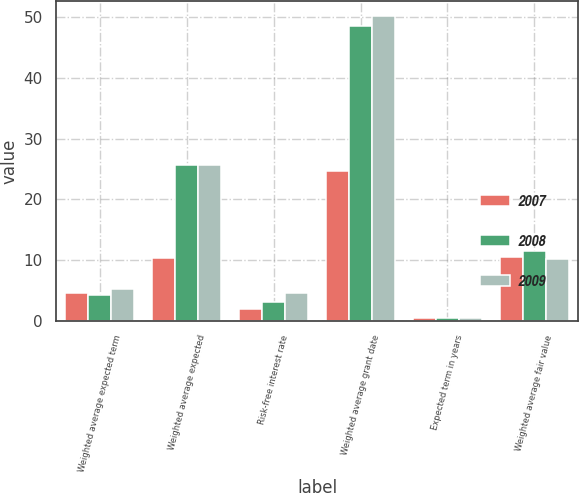Convert chart to OTSL. <chart><loc_0><loc_0><loc_500><loc_500><stacked_bar_chart><ecel><fcel>Weighted average expected term<fcel>Weighted average expected<fcel>Risk-free interest rate<fcel>Weighted average grant date<fcel>Expected term in years<fcel>Weighted average fair value<nl><fcel>2007<fcel>4.5<fcel>10.36<fcel>2<fcel>24.61<fcel>0.5<fcel>10.53<nl><fcel>2008<fcel>4.3<fcel>25.7<fcel>3.07<fcel>48.57<fcel>0.5<fcel>11.45<nl><fcel>2009<fcel>5.3<fcel>25.6<fcel>4.6<fcel>50.15<fcel>0.5<fcel>10.19<nl></chart> 